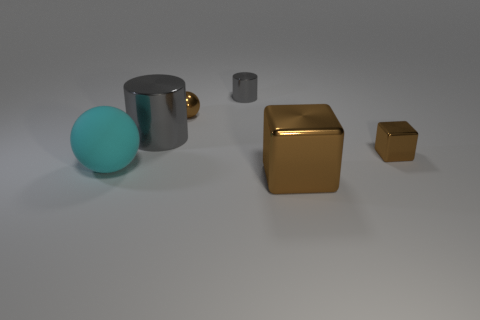Can you describe the colors and the shapes of the objects in the image? Certainly! There are three distinct items. Starting from the left, there's a large teal sphere, then a silver cylindrical mug with a handle, and on the right, two cubes - a large gold one and a smaller bronze-toned one. 